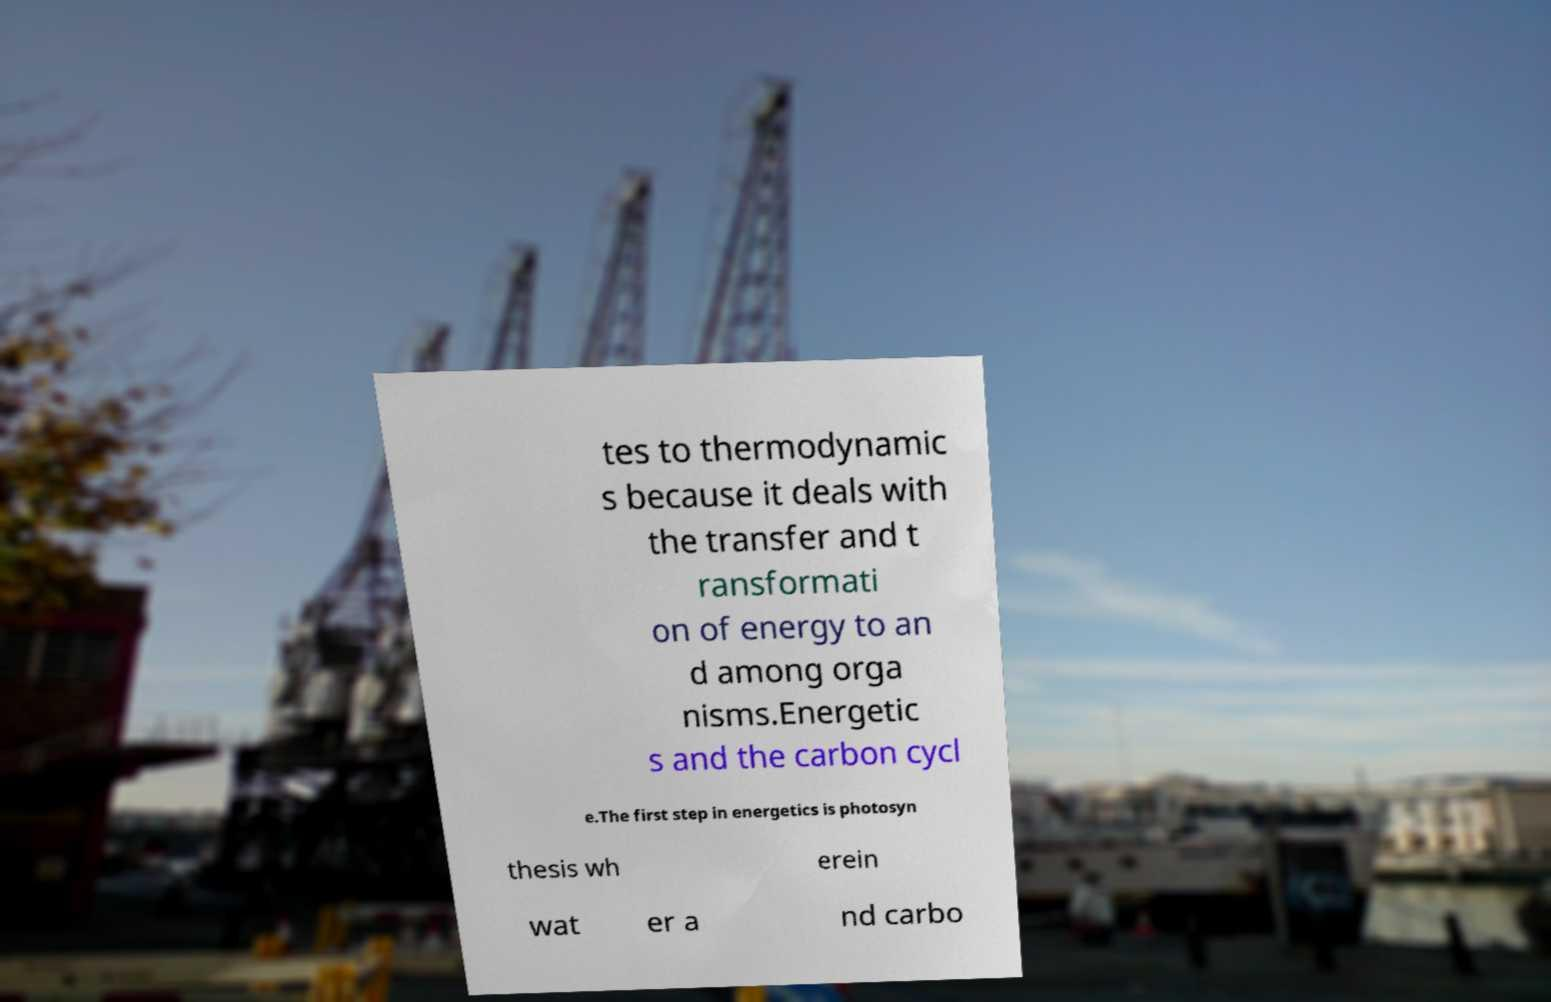There's text embedded in this image that I need extracted. Can you transcribe it verbatim? tes to thermodynamic s because it deals with the transfer and t ransformati on of energy to an d among orga nisms.Energetic s and the carbon cycl e.The first step in energetics is photosyn thesis wh erein wat er a nd carbo 